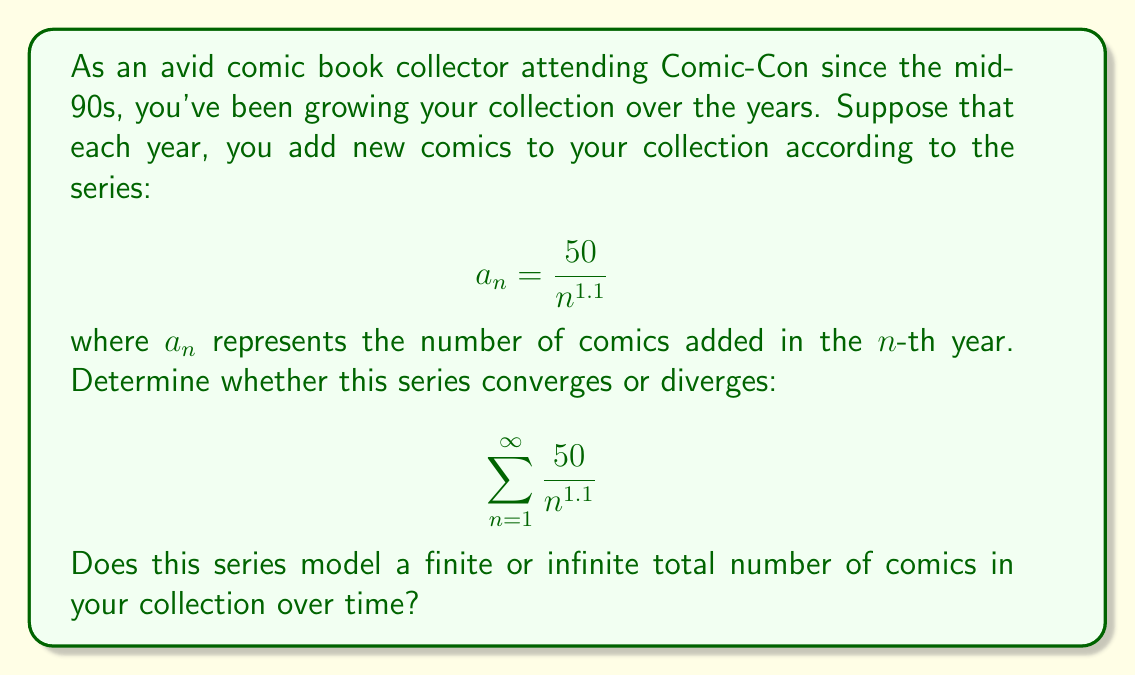Solve this math problem. To determine the convergence of this series, we can use the p-series test:

1) The general form of a p-series is:

   $$\sum_{n=1}^{\infty} \frac{1}{n^p}$$

2) Our series can be rewritten as:

   $$\sum_{n=1}^{\infty} \frac{50}{n^{1.1}} = 50 \sum_{n=1}^{\infty} \frac{1}{n^{1.1}}$$

3) In our case, $p = 1.1$

4) The p-series test states:
   - If $p > 1$, the series converges
   - If $p \leq 1$, the series diverges

5) Since $1.1 > 1$, our series converges.

6) The convergence of this series means that the sum of all terms is finite. In the context of our comic book collection, this implies that the total number of comics added over infinite years is finite.

7) However, it's important to note that while the series converges mathematically, in reality, the model suggests that you're adding fewer comics each year (as $n$ increases, $\frac{50}{n^{1.1}}$ decreases). This could represent a realistic scenario where your collecting habits slow down over time, but you continue to add to your collection indefinitely.
Answer: The series $\sum_{n=1}^{\infty} \frac{50}{n^{1.1}}$ converges. This models a finite total number of comics added to the collection over an infinite time period, suggesting a gradually slowing but ongoing growth of the comic book collection. 